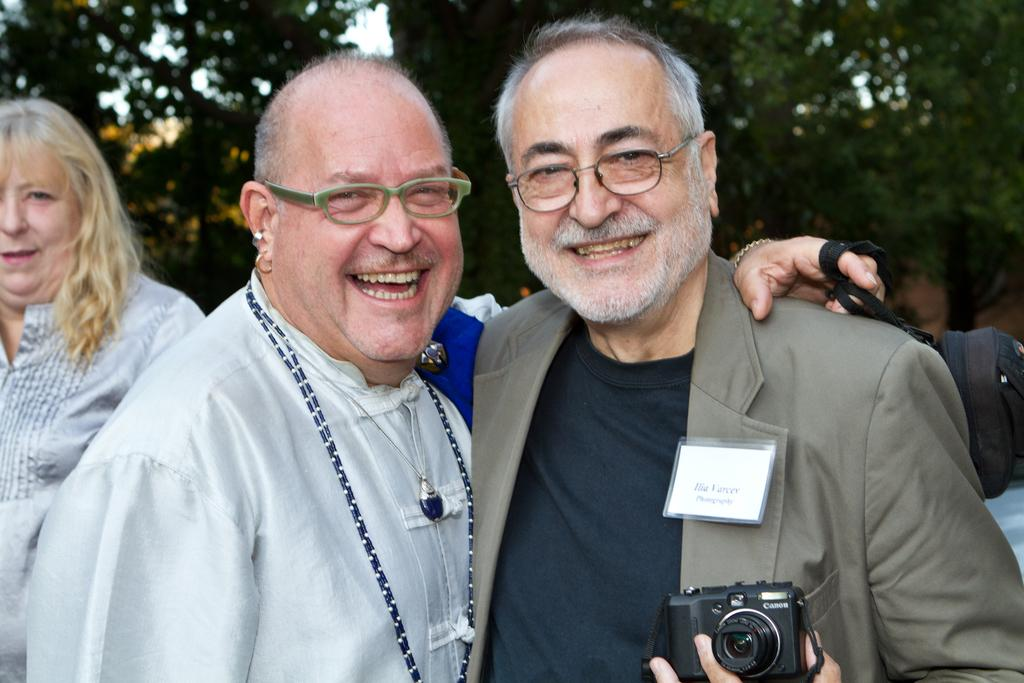How many people are in the foreground of the image? There are two persons in the foreground of the image. What are the two persons holding in their hands? The two persons are holding a camera in their hands. Can you describe the background of the image? There is a woman, trees, and the sky visible in the background of the image. What time of day was the image taken? The image was taken during the day. What type of berry can be seen growing on the trees in the background of the image? There are no berries visible on the trees in the background of the image. How does the death of the woman in the background of the image affect the two persons in the foreground? There is no indication of death or any negative event in the image, so it cannot be determined how it would affect the two persons in the foreground. 